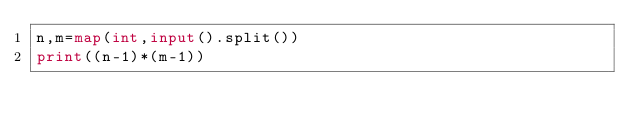<code> <loc_0><loc_0><loc_500><loc_500><_Python_>n,m=map(int,input().split())
print((n-1)*(m-1))</code> 